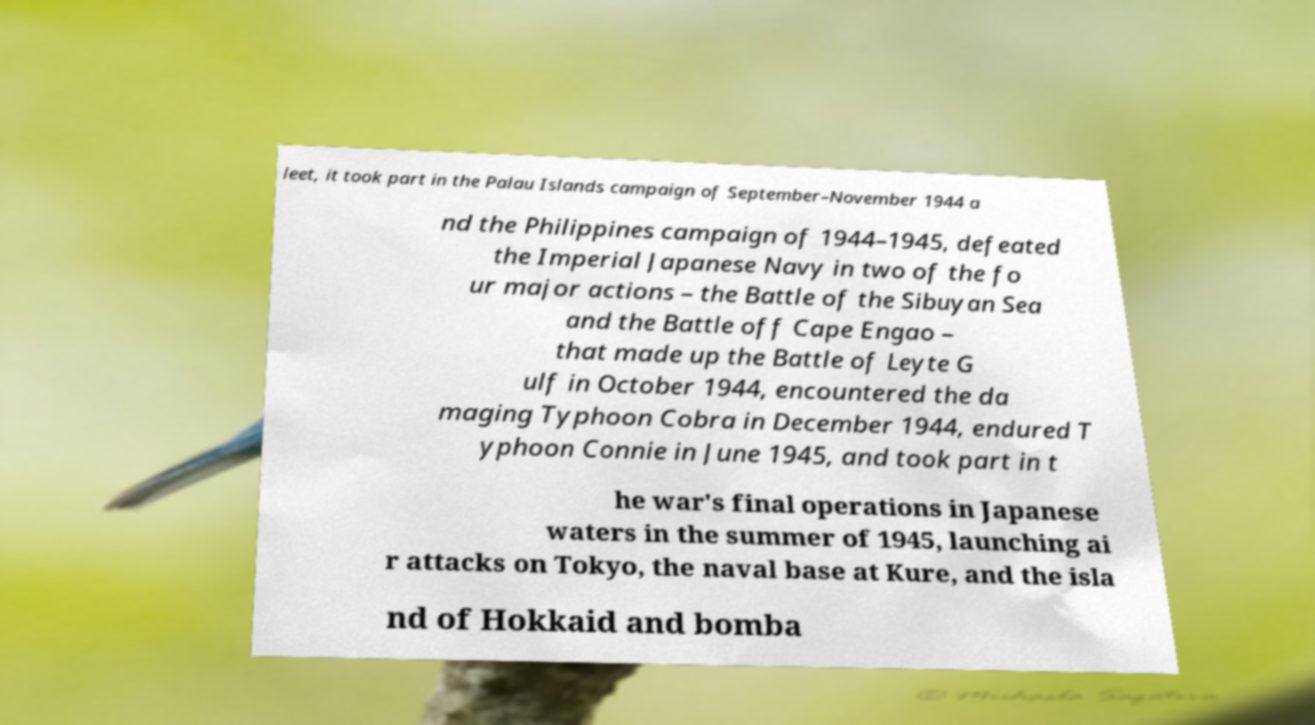Please identify and transcribe the text found in this image. leet, it took part in the Palau Islands campaign of September–November 1944 a nd the Philippines campaign of 1944–1945, defeated the Imperial Japanese Navy in two of the fo ur major actions – the Battle of the Sibuyan Sea and the Battle off Cape Engao – that made up the Battle of Leyte G ulf in October 1944, encountered the da maging Typhoon Cobra in December 1944, endured T yphoon Connie in June 1945, and took part in t he war's final operations in Japanese waters in the summer of 1945, launching ai r attacks on Tokyo, the naval base at Kure, and the isla nd of Hokkaid and bomba 